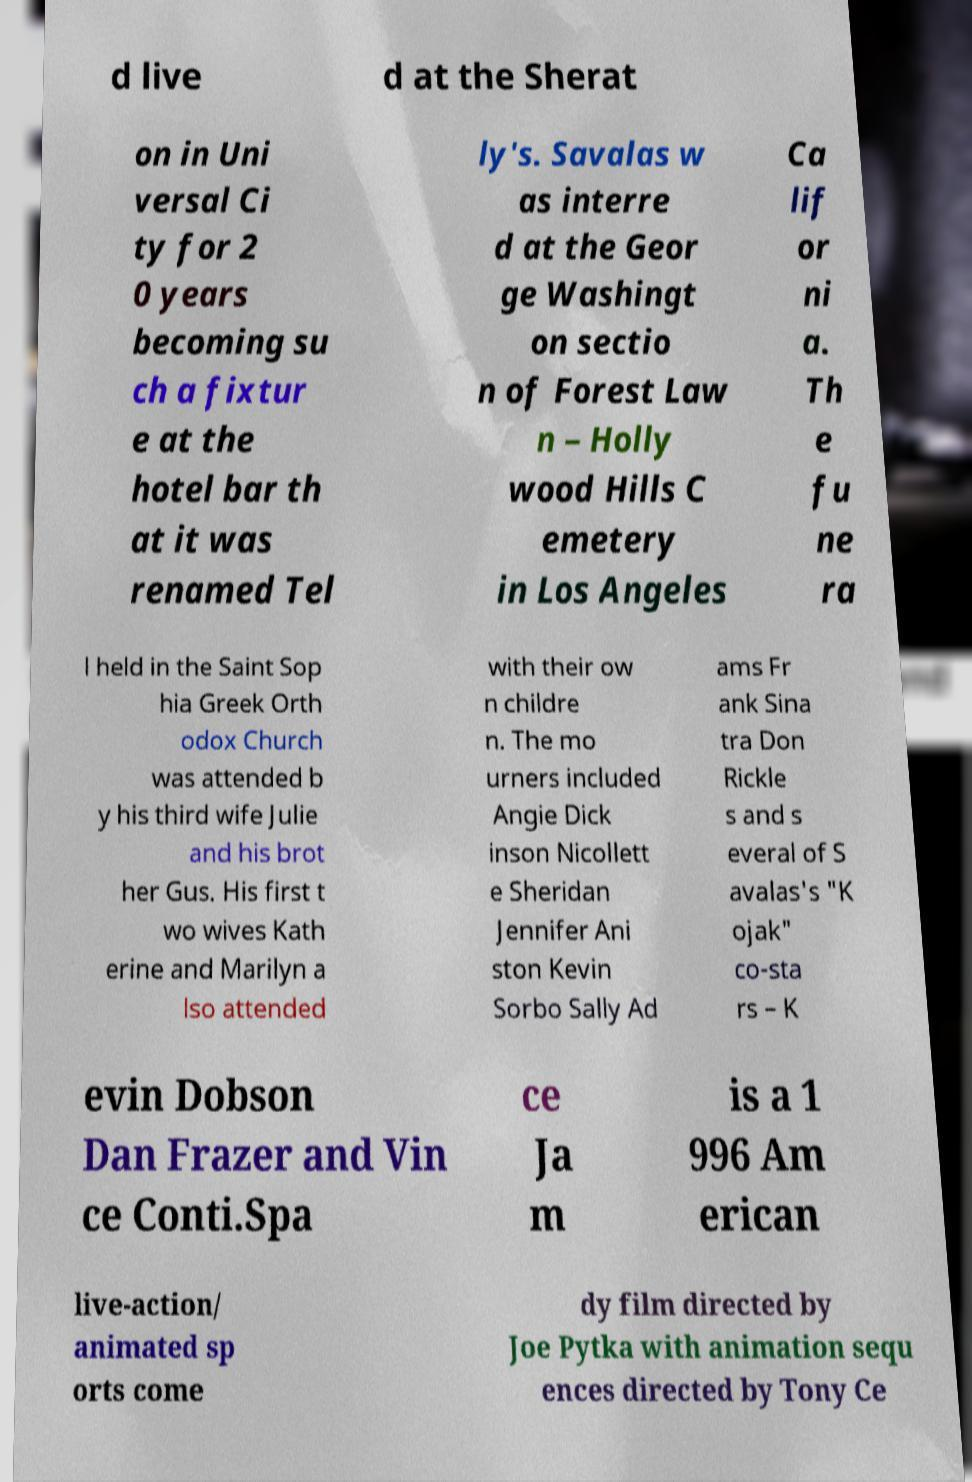Please read and relay the text visible in this image. What does it say? d live d at the Sherat on in Uni versal Ci ty for 2 0 years becoming su ch a fixtur e at the hotel bar th at it was renamed Tel ly's. Savalas w as interre d at the Geor ge Washingt on sectio n of Forest Law n – Holly wood Hills C emetery in Los Angeles Ca lif or ni a. Th e fu ne ra l held in the Saint Sop hia Greek Orth odox Church was attended b y his third wife Julie and his brot her Gus. His first t wo wives Kath erine and Marilyn a lso attended with their ow n childre n. The mo urners included Angie Dick inson Nicollett e Sheridan Jennifer Ani ston Kevin Sorbo Sally Ad ams Fr ank Sina tra Don Rickle s and s everal of S avalas's "K ojak" co-sta rs – K evin Dobson Dan Frazer and Vin ce Conti.Spa ce Ja m is a 1 996 Am erican live-action/ animated sp orts come dy film directed by Joe Pytka with animation sequ ences directed by Tony Ce 